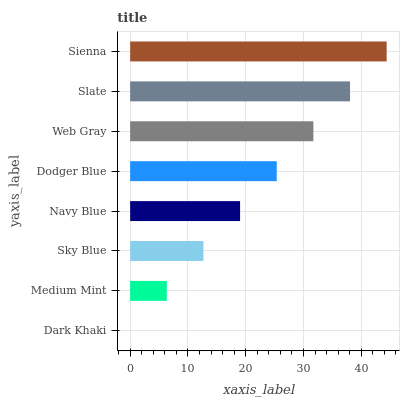Is Dark Khaki the minimum?
Answer yes or no. Yes. Is Sienna the maximum?
Answer yes or no. Yes. Is Medium Mint the minimum?
Answer yes or no. No. Is Medium Mint the maximum?
Answer yes or no. No. Is Medium Mint greater than Dark Khaki?
Answer yes or no. Yes. Is Dark Khaki less than Medium Mint?
Answer yes or no. Yes. Is Dark Khaki greater than Medium Mint?
Answer yes or no. No. Is Medium Mint less than Dark Khaki?
Answer yes or no. No. Is Dodger Blue the high median?
Answer yes or no. Yes. Is Navy Blue the low median?
Answer yes or no. Yes. Is Navy Blue the high median?
Answer yes or no. No. Is Web Gray the low median?
Answer yes or no. No. 